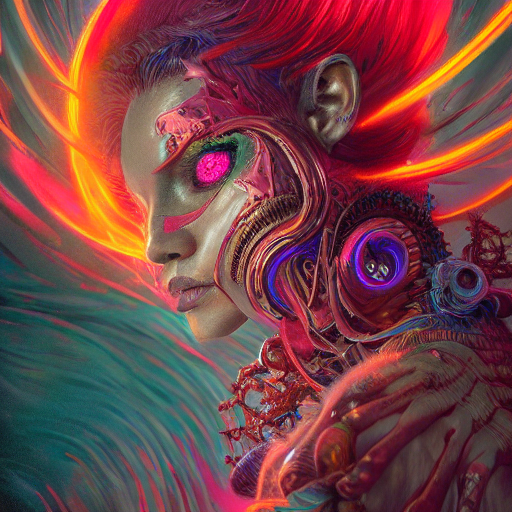Could you tell me more about the artistic style used? The artistic style is reminiscent of digital painting with vibrant colors and dynamic strokes, giving it a sense of motion. The details in both the mechanical and organic elements indicate a careful balance between realism and fantastical design. How might this image be interpreted symbolically? Symbolically, the image could represent the intersection of humanity's natural essence with the advancement of technology. It might be expressing a perspective on the potential harmony or conflict between our biological origins and artificial enhancements. 